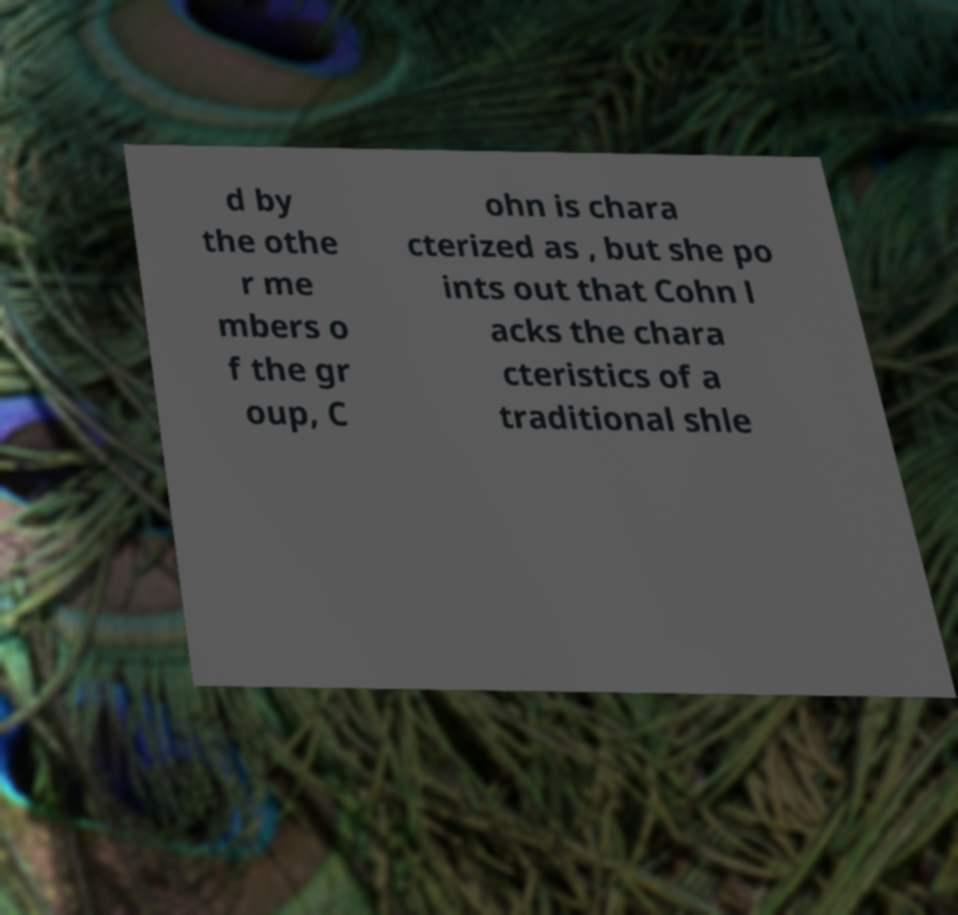There's text embedded in this image that I need extracted. Can you transcribe it verbatim? d by the othe r me mbers o f the gr oup, C ohn is chara cterized as , but she po ints out that Cohn l acks the chara cteristics of a traditional shle 